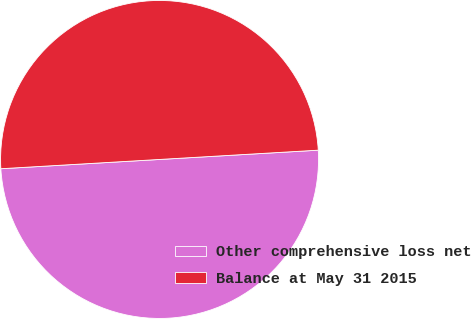Convert chart to OTSL. <chart><loc_0><loc_0><loc_500><loc_500><pie_chart><fcel>Other comprehensive loss net<fcel>Balance at May 31 2015<nl><fcel>50.0%<fcel>50.0%<nl></chart> 